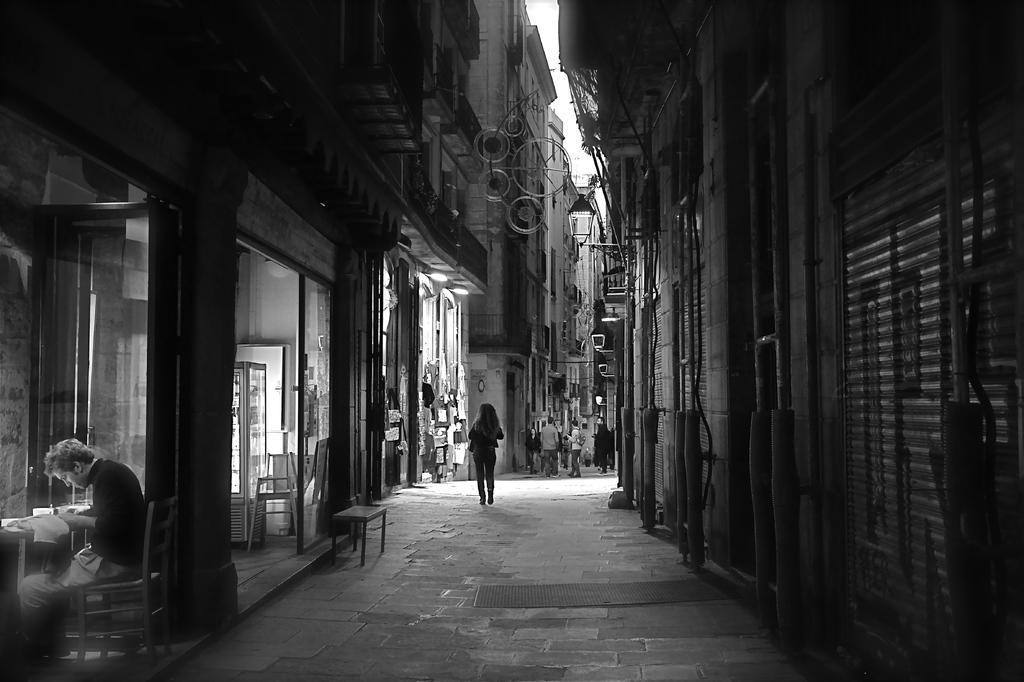Could you give a brief overview of what you see in this image? This is a black and white image. On the right there are buildings, pipes, shutters. On the left there are buildings, doors, people and many objects. In the center of the picture it is path. In the center of the background there are people walking down the path. 